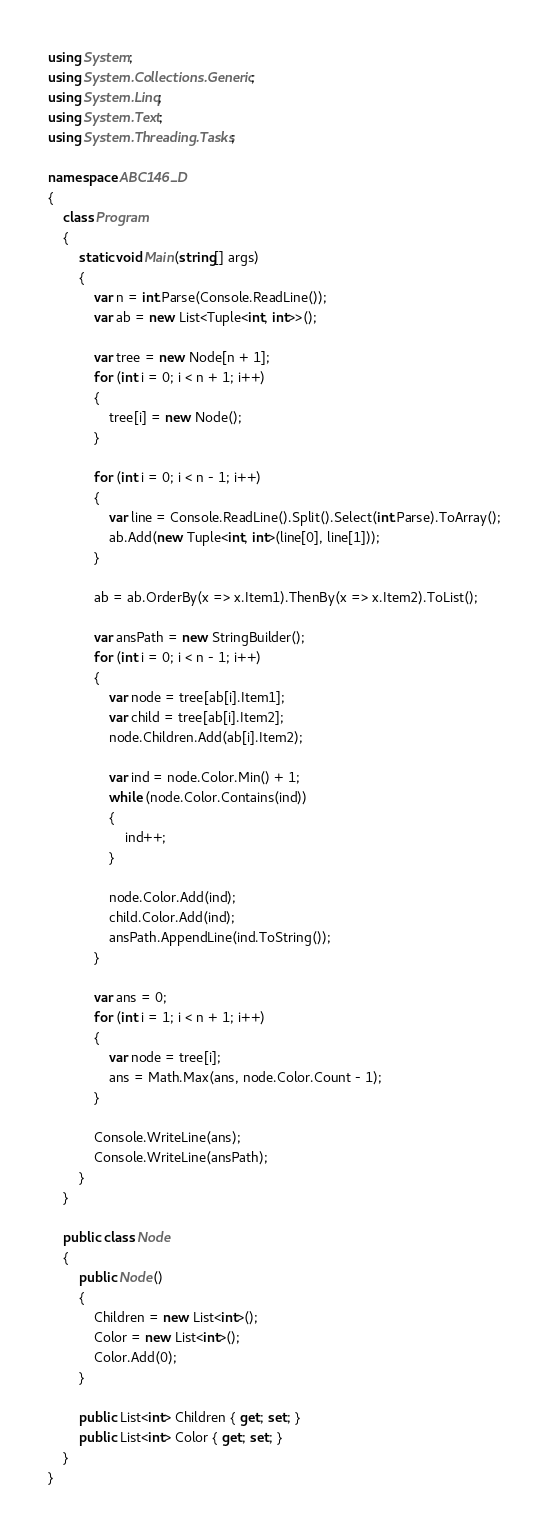<code> <loc_0><loc_0><loc_500><loc_500><_C#_>using System;
using System.Collections.Generic;
using System.Linq;
using System.Text;
using System.Threading.Tasks;

namespace ABC146_D
{
    class Program
    {
        static void Main(string[] args)
        {
            var n = int.Parse(Console.ReadLine());
            var ab = new List<Tuple<int, int>>();

            var tree = new Node[n + 1];
            for (int i = 0; i < n + 1; i++)
            {
                tree[i] = new Node();
            }

            for (int i = 0; i < n - 1; i++)
            {
                var line = Console.ReadLine().Split().Select(int.Parse).ToArray();
                ab.Add(new Tuple<int, int>(line[0], line[1]));
            }

            ab = ab.OrderBy(x => x.Item1).ThenBy(x => x.Item2).ToList();

            var ansPath = new StringBuilder();
            for (int i = 0; i < n - 1; i++)
            {
                var node = tree[ab[i].Item1];
                var child = tree[ab[i].Item2];
                node.Children.Add(ab[i].Item2);

                var ind = node.Color.Min() + 1;
                while (node.Color.Contains(ind))
                {
                    ind++;
                }

                node.Color.Add(ind);
                child.Color.Add(ind);
                ansPath.AppendLine(ind.ToString());
            }

            var ans = 0;
            for (int i = 1; i < n + 1; i++)
            {
                var node = tree[i];
                ans = Math.Max(ans, node.Color.Count - 1);
            }

            Console.WriteLine(ans);
            Console.WriteLine(ansPath);
        }
    }

    public class Node
    {
        public Node()
        {
            Children = new List<int>();
            Color = new List<int>();
            Color.Add(0);
        }

        public List<int> Children { get; set; }
        public List<int> Color { get; set; }
    }
}
</code> 